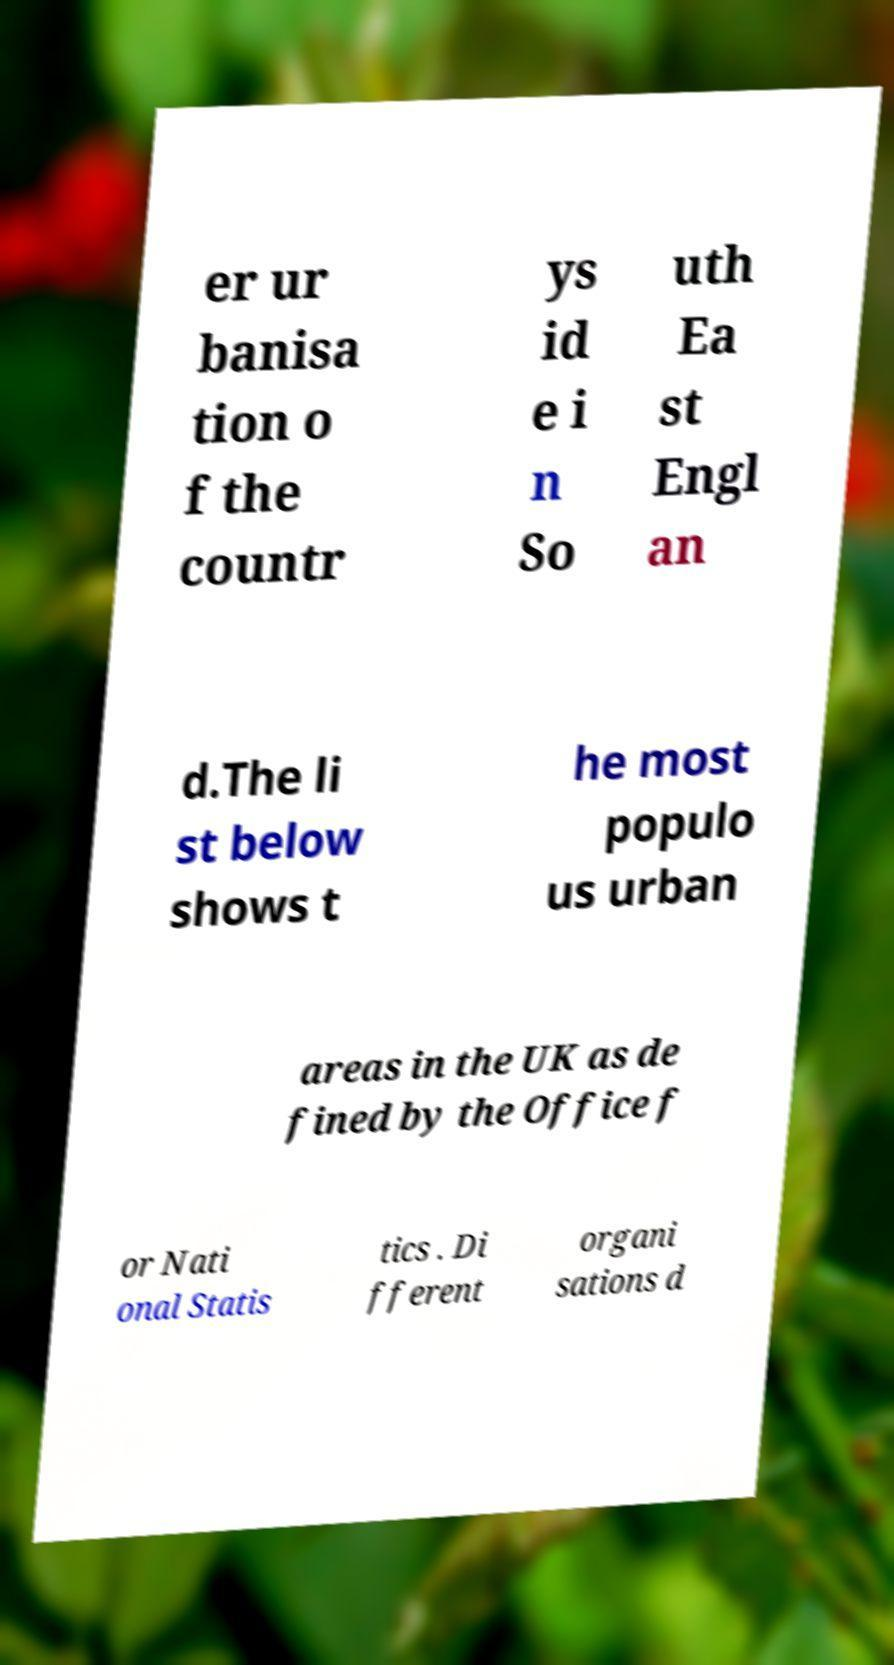For documentation purposes, I need the text within this image transcribed. Could you provide that? er ur banisa tion o f the countr ys id e i n So uth Ea st Engl an d.The li st below shows t he most populo us urban areas in the UK as de fined by the Office f or Nati onal Statis tics . Di fferent organi sations d 